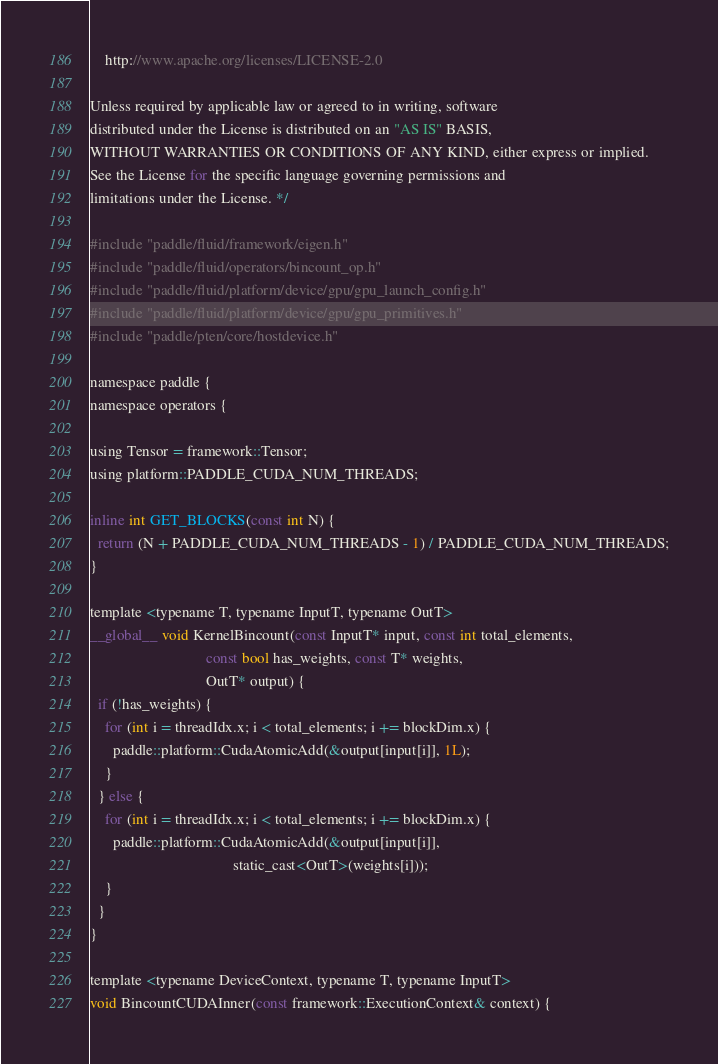Convert code to text. <code><loc_0><loc_0><loc_500><loc_500><_Cuda_>    http://www.apache.org/licenses/LICENSE-2.0

Unless required by applicable law or agreed to in writing, software
distributed under the License is distributed on an "AS IS" BASIS,
WITHOUT WARRANTIES OR CONDITIONS OF ANY KIND, either express or implied.
See the License for the specific language governing permissions and
limitations under the License. */

#include "paddle/fluid/framework/eigen.h"
#include "paddle/fluid/operators/bincount_op.h"
#include "paddle/fluid/platform/device/gpu/gpu_launch_config.h"
#include "paddle/fluid/platform/device/gpu/gpu_primitives.h"
#include "paddle/pten/core/hostdevice.h"

namespace paddle {
namespace operators {

using Tensor = framework::Tensor;
using platform::PADDLE_CUDA_NUM_THREADS;

inline int GET_BLOCKS(const int N) {
  return (N + PADDLE_CUDA_NUM_THREADS - 1) / PADDLE_CUDA_NUM_THREADS;
}

template <typename T, typename InputT, typename OutT>
__global__ void KernelBincount(const InputT* input, const int total_elements,
                               const bool has_weights, const T* weights,
                               OutT* output) {
  if (!has_weights) {
    for (int i = threadIdx.x; i < total_elements; i += blockDim.x) {
      paddle::platform::CudaAtomicAdd(&output[input[i]], 1L);
    }
  } else {
    for (int i = threadIdx.x; i < total_elements; i += blockDim.x) {
      paddle::platform::CudaAtomicAdd(&output[input[i]],
                                      static_cast<OutT>(weights[i]));
    }
  }
}

template <typename DeviceContext, typename T, typename InputT>
void BincountCUDAInner(const framework::ExecutionContext& context) {</code> 